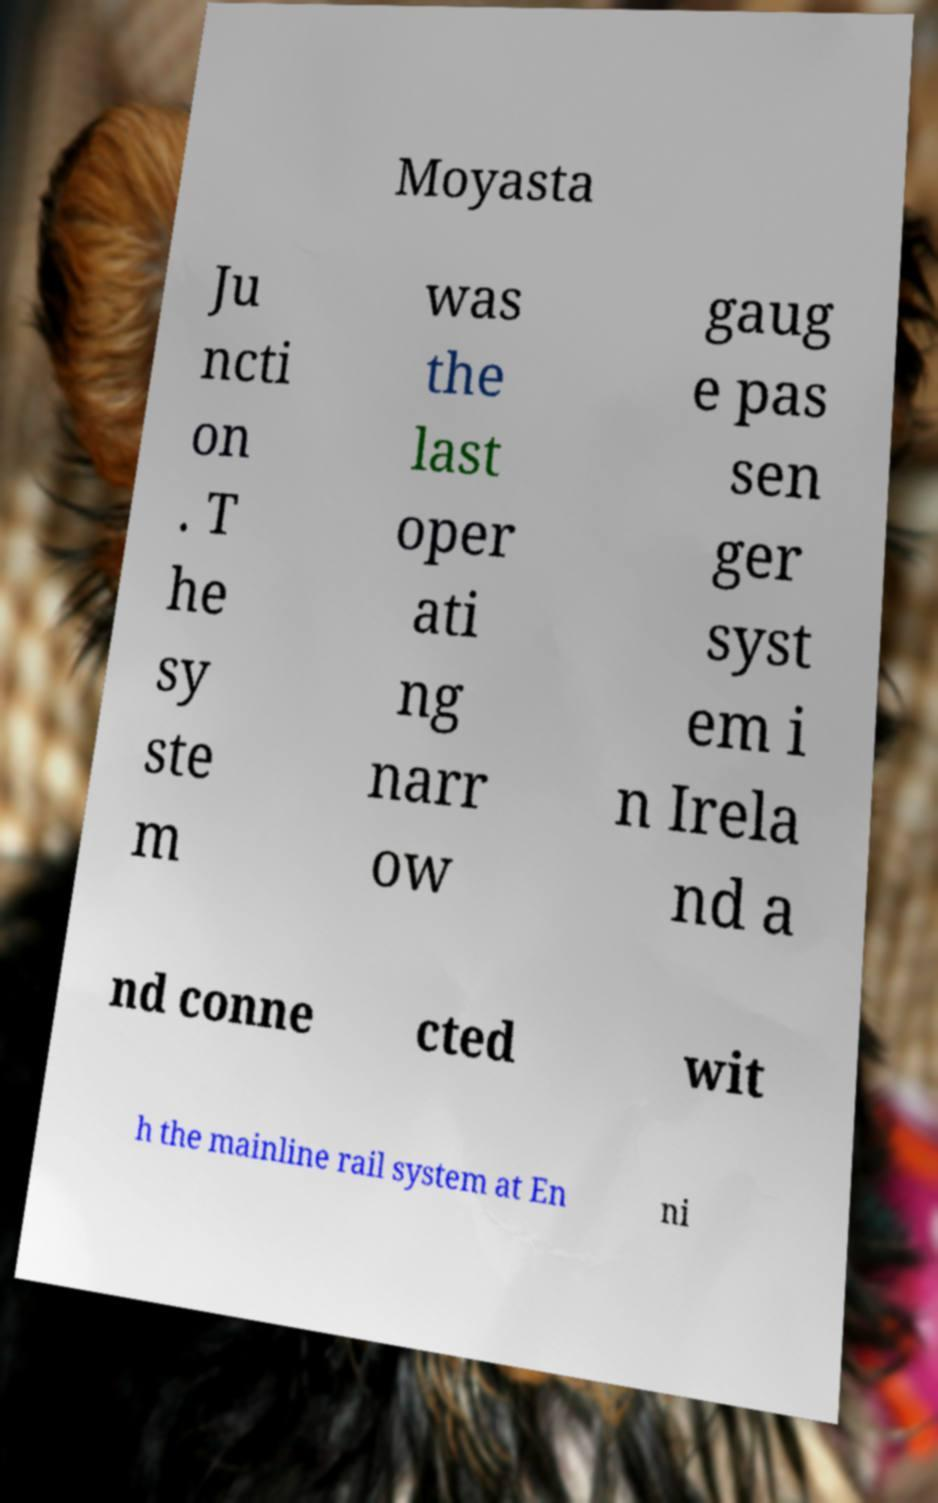I need the written content from this picture converted into text. Can you do that? Moyasta Ju ncti on . T he sy ste m was the last oper ati ng narr ow gaug e pas sen ger syst em i n Irela nd a nd conne cted wit h the mainline rail system at En ni 